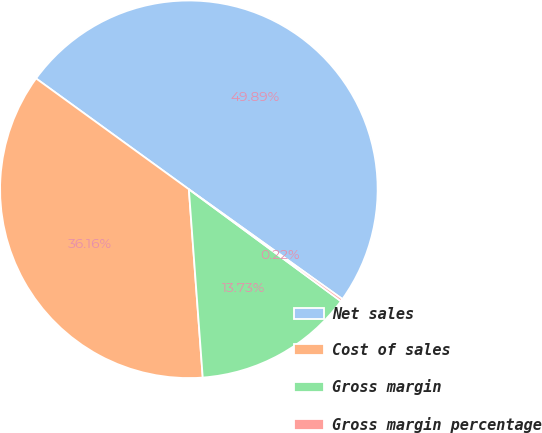Convert chart to OTSL. <chart><loc_0><loc_0><loc_500><loc_500><pie_chart><fcel>Net sales<fcel>Cost of sales<fcel>Gross margin<fcel>Gross margin percentage<nl><fcel>49.89%<fcel>36.16%<fcel>13.73%<fcel>0.22%<nl></chart> 